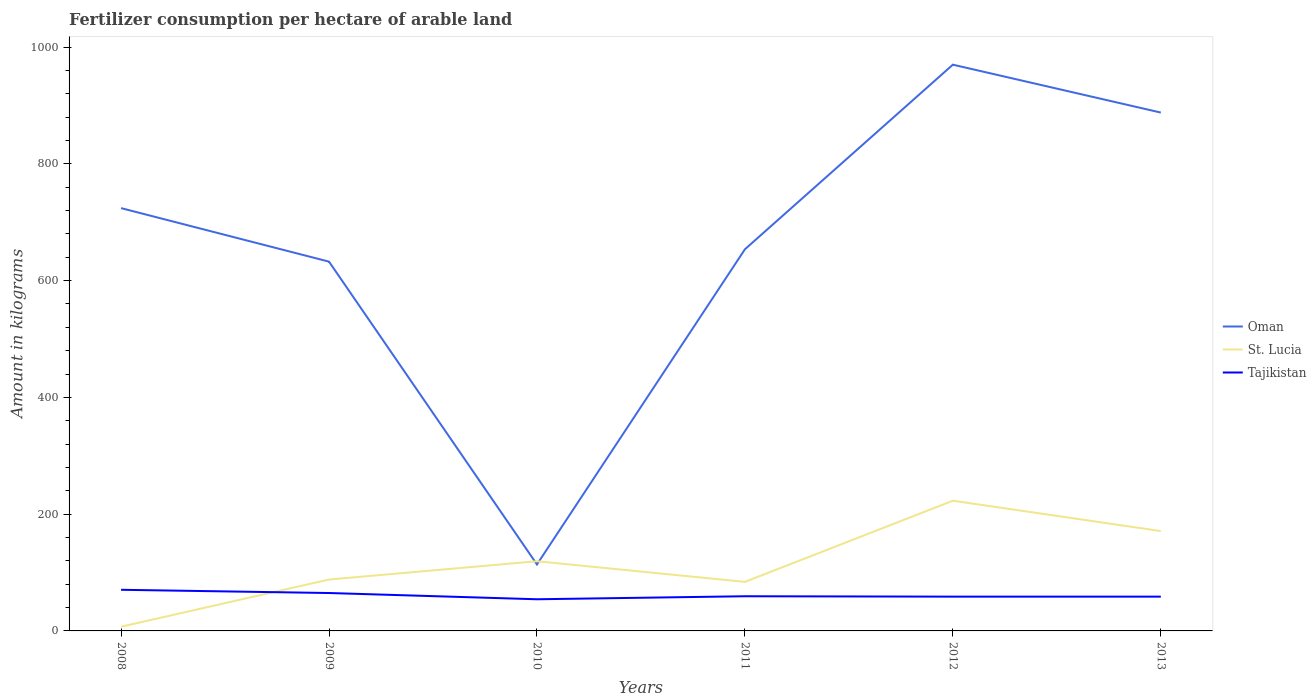Does the line corresponding to Tajikistan intersect with the line corresponding to St. Lucia?
Offer a terse response. Yes. Is the number of lines equal to the number of legend labels?
Keep it short and to the point. Yes. Across all years, what is the maximum amount of fertilizer consumption in Tajikistan?
Your answer should be very brief. 54.22. In which year was the amount of fertilizer consumption in Tajikistan maximum?
Your response must be concise. 2010. What is the total amount of fertilizer consumption in St. Lucia in the graph?
Ensure brevity in your answer.  -80.8. What is the difference between the highest and the second highest amount of fertilizer consumption in Tajikistan?
Provide a succinct answer. 16.23. How many lines are there?
Your response must be concise. 3. Are the values on the major ticks of Y-axis written in scientific E-notation?
Offer a very short reply. No. Where does the legend appear in the graph?
Your answer should be very brief. Center right. How are the legend labels stacked?
Give a very brief answer. Vertical. What is the title of the graph?
Keep it short and to the point. Fertilizer consumption per hectare of arable land. Does "Cyprus" appear as one of the legend labels in the graph?
Make the answer very short. No. What is the label or title of the X-axis?
Ensure brevity in your answer.  Years. What is the label or title of the Y-axis?
Ensure brevity in your answer.  Amount in kilograms. What is the Amount in kilograms in Oman in 2008?
Your answer should be compact. 724.1. What is the Amount in kilograms in St. Lucia in 2008?
Offer a very short reply. 7.2. What is the Amount in kilograms of Tajikistan in 2008?
Your response must be concise. 70.45. What is the Amount in kilograms in Oman in 2009?
Offer a terse response. 632.43. What is the Amount in kilograms of St. Lucia in 2009?
Your answer should be very brief. 88. What is the Amount in kilograms of Tajikistan in 2009?
Ensure brevity in your answer.  64.93. What is the Amount in kilograms of Oman in 2010?
Offer a very short reply. 113.88. What is the Amount in kilograms in St. Lucia in 2010?
Give a very brief answer. 119.33. What is the Amount in kilograms of Tajikistan in 2010?
Keep it short and to the point. 54.22. What is the Amount in kilograms of Oman in 2011?
Make the answer very short. 653.6. What is the Amount in kilograms of St. Lucia in 2011?
Provide a short and direct response. 84. What is the Amount in kilograms of Tajikistan in 2011?
Give a very brief answer. 59.39. What is the Amount in kilograms in Oman in 2012?
Make the answer very short. 969.76. What is the Amount in kilograms in St. Lucia in 2012?
Provide a succinct answer. 223. What is the Amount in kilograms in Tajikistan in 2012?
Provide a short and direct response. 58.72. What is the Amount in kilograms of Oman in 2013?
Your answer should be compact. 887.75. What is the Amount in kilograms in St. Lucia in 2013?
Provide a short and direct response. 171. What is the Amount in kilograms of Tajikistan in 2013?
Offer a very short reply. 58.72. Across all years, what is the maximum Amount in kilograms in Oman?
Offer a terse response. 969.76. Across all years, what is the maximum Amount in kilograms in St. Lucia?
Your answer should be compact. 223. Across all years, what is the maximum Amount in kilograms of Tajikistan?
Your answer should be compact. 70.45. Across all years, what is the minimum Amount in kilograms in Oman?
Provide a short and direct response. 113.88. Across all years, what is the minimum Amount in kilograms in Tajikistan?
Provide a succinct answer. 54.22. What is the total Amount in kilograms of Oman in the graph?
Offer a very short reply. 3981.52. What is the total Amount in kilograms in St. Lucia in the graph?
Ensure brevity in your answer.  692.53. What is the total Amount in kilograms of Tajikistan in the graph?
Make the answer very short. 366.43. What is the difference between the Amount in kilograms in Oman in 2008 and that in 2009?
Your answer should be compact. 91.67. What is the difference between the Amount in kilograms in St. Lucia in 2008 and that in 2009?
Your response must be concise. -80.8. What is the difference between the Amount in kilograms of Tajikistan in 2008 and that in 2009?
Keep it short and to the point. 5.52. What is the difference between the Amount in kilograms in Oman in 2008 and that in 2010?
Your answer should be very brief. 610.22. What is the difference between the Amount in kilograms in St. Lucia in 2008 and that in 2010?
Ensure brevity in your answer.  -112.13. What is the difference between the Amount in kilograms of Tajikistan in 2008 and that in 2010?
Offer a terse response. 16.23. What is the difference between the Amount in kilograms of Oman in 2008 and that in 2011?
Ensure brevity in your answer.  70.5. What is the difference between the Amount in kilograms in St. Lucia in 2008 and that in 2011?
Make the answer very short. -76.8. What is the difference between the Amount in kilograms of Tajikistan in 2008 and that in 2011?
Make the answer very short. 11.05. What is the difference between the Amount in kilograms in Oman in 2008 and that in 2012?
Make the answer very short. -245.66. What is the difference between the Amount in kilograms in St. Lucia in 2008 and that in 2012?
Your answer should be compact. -215.8. What is the difference between the Amount in kilograms in Tajikistan in 2008 and that in 2012?
Ensure brevity in your answer.  11.72. What is the difference between the Amount in kilograms in Oman in 2008 and that in 2013?
Your answer should be compact. -163.65. What is the difference between the Amount in kilograms in St. Lucia in 2008 and that in 2013?
Provide a succinct answer. -163.8. What is the difference between the Amount in kilograms of Tajikistan in 2008 and that in 2013?
Offer a terse response. 11.72. What is the difference between the Amount in kilograms in Oman in 2009 and that in 2010?
Your answer should be compact. 518.55. What is the difference between the Amount in kilograms of St. Lucia in 2009 and that in 2010?
Ensure brevity in your answer.  -31.33. What is the difference between the Amount in kilograms of Tajikistan in 2009 and that in 2010?
Your answer should be compact. 10.71. What is the difference between the Amount in kilograms in Oman in 2009 and that in 2011?
Your answer should be compact. -21.17. What is the difference between the Amount in kilograms of St. Lucia in 2009 and that in 2011?
Offer a very short reply. 4. What is the difference between the Amount in kilograms in Tajikistan in 2009 and that in 2011?
Provide a short and direct response. 5.54. What is the difference between the Amount in kilograms in Oman in 2009 and that in 2012?
Your response must be concise. -337.33. What is the difference between the Amount in kilograms of St. Lucia in 2009 and that in 2012?
Provide a short and direct response. -135. What is the difference between the Amount in kilograms in Tajikistan in 2009 and that in 2012?
Provide a short and direct response. 6.21. What is the difference between the Amount in kilograms in Oman in 2009 and that in 2013?
Keep it short and to the point. -255.31. What is the difference between the Amount in kilograms in St. Lucia in 2009 and that in 2013?
Provide a short and direct response. -83. What is the difference between the Amount in kilograms in Tajikistan in 2009 and that in 2013?
Your answer should be very brief. 6.21. What is the difference between the Amount in kilograms in Oman in 2010 and that in 2011?
Make the answer very short. -539.73. What is the difference between the Amount in kilograms of St. Lucia in 2010 and that in 2011?
Offer a very short reply. 35.33. What is the difference between the Amount in kilograms in Tajikistan in 2010 and that in 2011?
Offer a terse response. -5.17. What is the difference between the Amount in kilograms of Oman in 2010 and that in 2012?
Your response must be concise. -855.89. What is the difference between the Amount in kilograms in St. Lucia in 2010 and that in 2012?
Your answer should be compact. -103.67. What is the difference between the Amount in kilograms of Tajikistan in 2010 and that in 2012?
Provide a succinct answer. -4.5. What is the difference between the Amount in kilograms in Oman in 2010 and that in 2013?
Your response must be concise. -773.87. What is the difference between the Amount in kilograms in St. Lucia in 2010 and that in 2013?
Keep it short and to the point. -51.67. What is the difference between the Amount in kilograms of Tajikistan in 2010 and that in 2013?
Provide a succinct answer. -4.5. What is the difference between the Amount in kilograms of Oman in 2011 and that in 2012?
Offer a terse response. -316.16. What is the difference between the Amount in kilograms in St. Lucia in 2011 and that in 2012?
Offer a terse response. -139. What is the difference between the Amount in kilograms in Tajikistan in 2011 and that in 2012?
Your answer should be very brief. 0.67. What is the difference between the Amount in kilograms in Oman in 2011 and that in 2013?
Provide a short and direct response. -234.14. What is the difference between the Amount in kilograms in St. Lucia in 2011 and that in 2013?
Give a very brief answer. -87. What is the difference between the Amount in kilograms in Tajikistan in 2011 and that in 2013?
Your answer should be very brief. 0.67. What is the difference between the Amount in kilograms of Oman in 2012 and that in 2013?
Give a very brief answer. 82.02. What is the difference between the Amount in kilograms in St. Lucia in 2012 and that in 2013?
Offer a very short reply. 52. What is the difference between the Amount in kilograms of Tajikistan in 2012 and that in 2013?
Make the answer very short. 0. What is the difference between the Amount in kilograms of Oman in 2008 and the Amount in kilograms of St. Lucia in 2009?
Your response must be concise. 636.1. What is the difference between the Amount in kilograms of Oman in 2008 and the Amount in kilograms of Tajikistan in 2009?
Keep it short and to the point. 659.17. What is the difference between the Amount in kilograms in St. Lucia in 2008 and the Amount in kilograms in Tajikistan in 2009?
Offer a very short reply. -57.73. What is the difference between the Amount in kilograms in Oman in 2008 and the Amount in kilograms in St. Lucia in 2010?
Offer a terse response. 604.77. What is the difference between the Amount in kilograms of Oman in 2008 and the Amount in kilograms of Tajikistan in 2010?
Make the answer very short. 669.88. What is the difference between the Amount in kilograms of St. Lucia in 2008 and the Amount in kilograms of Tajikistan in 2010?
Keep it short and to the point. -47.02. What is the difference between the Amount in kilograms in Oman in 2008 and the Amount in kilograms in St. Lucia in 2011?
Provide a succinct answer. 640.1. What is the difference between the Amount in kilograms in Oman in 2008 and the Amount in kilograms in Tajikistan in 2011?
Offer a terse response. 664.71. What is the difference between the Amount in kilograms of St. Lucia in 2008 and the Amount in kilograms of Tajikistan in 2011?
Provide a short and direct response. -52.19. What is the difference between the Amount in kilograms in Oman in 2008 and the Amount in kilograms in St. Lucia in 2012?
Provide a succinct answer. 501.1. What is the difference between the Amount in kilograms of Oman in 2008 and the Amount in kilograms of Tajikistan in 2012?
Offer a very short reply. 665.38. What is the difference between the Amount in kilograms of St. Lucia in 2008 and the Amount in kilograms of Tajikistan in 2012?
Make the answer very short. -51.52. What is the difference between the Amount in kilograms of Oman in 2008 and the Amount in kilograms of St. Lucia in 2013?
Your answer should be compact. 553.1. What is the difference between the Amount in kilograms in Oman in 2008 and the Amount in kilograms in Tajikistan in 2013?
Keep it short and to the point. 665.38. What is the difference between the Amount in kilograms in St. Lucia in 2008 and the Amount in kilograms in Tajikistan in 2013?
Your response must be concise. -51.52. What is the difference between the Amount in kilograms of Oman in 2009 and the Amount in kilograms of St. Lucia in 2010?
Keep it short and to the point. 513.1. What is the difference between the Amount in kilograms of Oman in 2009 and the Amount in kilograms of Tajikistan in 2010?
Provide a short and direct response. 578.21. What is the difference between the Amount in kilograms in St. Lucia in 2009 and the Amount in kilograms in Tajikistan in 2010?
Keep it short and to the point. 33.78. What is the difference between the Amount in kilograms of Oman in 2009 and the Amount in kilograms of St. Lucia in 2011?
Give a very brief answer. 548.43. What is the difference between the Amount in kilograms of Oman in 2009 and the Amount in kilograms of Tajikistan in 2011?
Your answer should be compact. 573.04. What is the difference between the Amount in kilograms in St. Lucia in 2009 and the Amount in kilograms in Tajikistan in 2011?
Give a very brief answer. 28.61. What is the difference between the Amount in kilograms in Oman in 2009 and the Amount in kilograms in St. Lucia in 2012?
Provide a short and direct response. 409.43. What is the difference between the Amount in kilograms in Oman in 2009 and the Amount in kilograms in Tajikistan in 2012?
Provide a succinct answer. 573.71. What is the difference between the Amount in kilograms of St. Lucia in 2009 and the Amount in kilograms of Tajikistan in 2012?
Provide a short and direct response. 29.28. What is the difference between the Amount in kilograms in Oman in 2009 and the Amount in kilograms in St. Lucia in 2013?
Your response must be concise. 461.43. What is the difference between the Amount in kilograms in Oman in 2009 and the Amount in kilograms in Tajikistan in 2013?
Provide a succinct answer. 573.71. What is the difference between the Amount in kilograms of St. Lucia in 2009 and the Amount in kilograms of Tajikistan in 2013?
Keep it short and to the point. 29.28. What is the difference between the Amount in kilograms of Oman in 2010 and the Amount in kilograms of St. Lucia in 2011?
Your response must be concise. 29.88. What is the difference between the Amount in kilograms in Oman in 2010 and the Amount in kilograms in Tajikistan in 2011?
Your answer should be very brief. 54.49. What is the difference between the Amount in kilograms in St. Lucia in 2010 and the Amount in kilograms in Tajikistan in 2011?
Provide a short and direct response. 59.94. What is the difference between the Amount in kilograms in Oman in 2010 and the Amount in kilograms in St. Lucia in 2012?
Ensure brevity in your answer.  -109.12. What is the difference between the Amount in kilograms of Oman in 2010 and the Amount in kilograms of Tajikistan in 2012?
Give a very brief answer. 55.16. What is the difference between the Amount in kilograms in St. Lucia in 2010 and the Amount in kilograms in Tajikistan in 2012?
Your response must be concise. 60.61. What is the difference between the Amount in kilograms of Oman in 2010 and the Amount in kilograms of St. Lucia in 2013?
Offer a very short reply. -57.12. What is the difference between the Amount in kilograms of Oman in 2010 and the Amount in kilograms of Tajikistan in 2013?
Provide a short and direct response. 55.16. What is the difference between the Amount in kilograms in St. Lucia in 2010 and the Amount in kilograms in Tajikistan in 2013?
Give a very brief answer. 60.61. What is the difference between the Amount in kilograms of Oman in 2011 and the Amount in kilograms of St. Lucia in 2012?
Ensure brevity in your answer.  430.6. What is the difference between the Amount in kilograms in Oman in 2011 and the Amount in kilograms in Tajikistan in 2012?
Your answer should be very brief. 594.88. What is the difference between the Amount in kilograms of St. Lucia in 2011 and the Amount in kilograms of Tajikistan in 2012?
Offer a very short reply. 25.28. What is the difference between the Amount in kilograms in Oman in 2011 and the Amount in kilograms in St. Lucia in 2013?
Offer a terse response. 482.6. What is the difference between the Amount in kilograms of Oman in 2011 and the Amount in kilograms of Tajikistan in 2013?
Your response must be concise. 594.88. What is the difference between the Amount in kilograms of St. Lucia in 2011 and the Amount in kilograms of Tajikistan in 2013?
Your answer should be very brief. 25.28. What is the difference between the Amount in kilograms of Oman in 2012 and the Amount in kilograms of St. Lucia in 2013?
Ensure brevity in your answer.  798.76. What is the difference between the Amount in kilograms in Oman in 2012 and the Amount in kilograms in Tajikistan in 2013?
Offer a terse response. 911.04. What is the difference between the Amount in kilograms in St. Lucia in 2012 and the Amount in kilograms in Tajikistan in 2013?
Offer a very short reply. 164.28. What is the average Amount in kilograms in Oman per year?
Offer a very short reply. 663.59. What is the average Amount in kilograms in St. Lucia per year?
Provide a short and direct response. 115.42. What is the average Amount in kilograms in Tajikistan per year?
Your response must be concise. 61.07. In the year 2008, what is the difference between the Amount in kilograms of Oman and Amount in kilograms of St. Lucia?
Keep it short and to the point. 716.9. In the year 2008, what is the difference between the Amount in kilograms in Oman and Amount in kilograms in Tajikistan?
Offer a very short reply. 653.65. In the year 2008, what is the difference between the Amount in kilograms of St. Lucia and Amount in kilograms of Tajikistan?
Ensure brevity in your answer.  -63.25. In the year 2009, what is the difference between the Amount in kilograms of Oman and Amount in kilograms of St. Lucia?
Provide a succinct answer. 544.43. In the year 2009, what is the difference between the Amount in kilograms of Oman and Amount in kilograms of Tajikistan?
Your response must be concise. 567.51. In the year 2009, what is the difference between the Amount in kilograms of St. Lucia and Amount in kilograms of Tajikistan?
Keep it short and to the point. 23.07. In the year 2010, what is the difference between the Amount in kilograms of Oman and Amount in kilograms of St. Lucia?
Make the answer very short. -5.46. In the year 2010, what is the difference between the Amount in kilograms of Oman and Amount in kilograms of Tajikistan?
Your answer should be compact. 59.66. In the year 2010, what is the difference between the Amount in kilograms in St. Lucia and Amount in kilograms in Tajikistan?
Provide a short and direct response. 65.11. In the year 2011, what is the difference between the Amount in kilograms in Oman and Amount in kilograms in St. Lucia?
Make the answer very short. 569.6. In the year 2011, what is the difference between the Amount in kilograms of Oman and Amount in kilograms of Tajikistan?
Your answer should be compact. 594.21. In the year 2011, what is the difference between the Amount in kilograms of St. Lucia and Amount in kilograms of Tajikistan?
Provide a succinct answer. 24.61. In the year 2012, what is the difference between the Amount in kilograms in Oman and Amount in kilograms in St. Lucia?
Your response must be concise. 746.76. In the year 2012, what is the difference between the Amount in kilograms in Oman and Amount in kilograms in Tajikistan?
Provide a succinct answer. 911.04. In the year 2012, what is the difference between the Amount in kilograms of St. Lucia and Amount in kilograms of Tajikistan?
Your response must be concise. 164.28. In the year 2013, what is the difference between the Amount in kilograms of Oman and Amount in kilograms of St. Lucia?
Offer a very short reply. 716.75. In the year 2013, what is the difference between the Amount in kilograms in Oman and Amount in kilograms in Tajikistan?
Keep it short and to the point. 829.02. In the year 2013, what is the difference between the Amount in kilograms of St. Lucia and Amount in kilograms of Tajikistan?
Your response must be concise. 112.28. What is the ratio of the Amount in kilograms of Oman in 2008 to that in 2009?
Ensure brevity in your answer.  1.14. What is the ratio of the Amount in kilograms in St. Lucia in 2008 to that in 2009?
Provide a succinct answer. 0.08. What is the ratio of the Amount in kilograms in Tajikistan in 2008 to that in 2009?
Keep it short and to the point. 1.08. What is the ratio of the Amount in kilograms of Oman in 2008 to that in 2010?
Your response must be concise. 6.36. What is the ratio of the Amount in kilograms of St. Lucia in 2008 to that in 2010?
Your answer should be compact. 0.06. What is the ratio of the Amount in kilograms of Tajikistan in 2008 to that in 2010?
Offer a terse response. 1.3. What is the ratio of the Amount in kilograms in Oman in 2008 to that in 2011?
Your response must be concise. 1.11. What is the ratio of the Amount in kilograms in St. Lucia in 2008 to that in 2011?
Your response must be concise. 0.09. What is the ratio of the Amount in kilograms in Tajikistan in 2008 to that in 2011?
Keep it short and to the point. 1.19. What is the ratio of the Amount in kilograms in Oman in 2008 to that in 2012?
Provide a short and direct response. 0.75. What is the ratio of the Amount in kilograms of St. Lucia in 2008 to that in 2012?
Ensure brevity in your answer.  0.03. What is the ratio of the Amount in kilograms in Tajikistan in 2008 to that in 2012?
Make the answer very short. 1.2. What is the ratio of the Amount in kilograms in Oman in 2008 to that in 2013?
Offer a terse response. 0.82. What is the ratio of the Amount in kilograms in St. Lucia in 2008 to that in 2013?
Your response must be concise. 0.04. What is the ratio of the Amount in kilograms in Tajikistan in 2008 to that in 2013?
Ensure brevity in your answer.  1.2. What is the ratio of the Amount in kilograms in Oman in 2009 to that in 2010?
Provide a short and direct response. 5.55. What is the ratio of the Amount in kilograms of St. Lucia in 2009 to that in 2010?
Offer a terse response. 0.74. What is the ratio of the Amount in kilograms of Tajikistan in 2009 to that in 2010?
Offer a very short reply. 1.2. What is the ratio of the Amount in kilograms of Oman in 2009 to that in 2011?
Give a very brief answer. 0.97. What is the ratio of the Amount in kilograms in St. Lucia in 2009 to that in 2011?
Your answer should be compact. 1.05. What is the ratio of the Amount in kilograms of Tajikistan in 2009 to that in 2011?
Keep it short and to the point. 1.09. What is the ratio of the Amount in kilograms of Oman in 2009 to that in 2012?
Keep it short and to the point. 0.65. What is the ratio of the Amount in kilograms in St. Lucia in 2009 to that in 2012?
Provide a short and direct response. 0.39. What is the ratio of the Amount in kilograms in Tajikistan in 2009 to that in 2012?
Your answer should be compact. 1.11. What is the ratio of the Amount in kilograms in Oman in 2009 to that in 2013?
Give a very brief answer. 0.71. What is the ratio of the Amount in kilograms of St. Lucia in 2009 to that in 2013?
Make the answer very short. 0.51. What is the ratio of the Amount in kilograms of Tajikistan in 2009 to that in 2013?
Your response must be concise. 1.11. What is the ratio of the Amount in kilograms in Oman in 2010 to that in 2011?
Provide a succinct answer. 0.17. What is the ratio of the Amount in kilograms of St. Lucia in 2010 to that in 2011?
Give a very brief answer. 1.42. What is the ratio of the Amount in kilograms of Tajikistan in 2010 to that in 2011?
Offer a very short reply. 0.91. What is the ratio of the Amount in kilograms in Oman in 2010 to that in 2012?
Make the answer very short. 0.12. What is the ratio of the Amount in kilograms in St. Lucia in 2010 to that in 2012?
Offer a terse response. 0.54. What is the ratio of the Amount in kilograms of Tajikistan in 2010 to that in 2012?
Keep it short and to the point. 0.92. What is the ratio of the Amount in kilograms in Oman in 2010 to that in 2013?
Ensure brevity in your answer.  0.13. What is the ratio of the Amount in kilograms in St. Lucia in 2010 to that in 2013?
Your response must be concise. 0.7. What is the ratio of the Amount in kilograms of Tajikistan in 2010 to that in 2013?
Ensure brevity in your answer.  0.92. What is the ratio of the Amount in kilograms in Oman in 2011 to that in 2012?
Your answer should be compact. 0.67. What is the ratio of the Amount in kilograms in St. Lucia in 2011 to that in 2012?
Provide a succinct answer. 0.38. What is the ratio of the Amount in kilograms of Tajikistan in 2011 to that in 2012?
Your answer should be compact. 1.01. What is the ratio of the Amount in kilograms of Oman in 2011 to that in 2013?
Offer a terse response. 0.74. What is the ratio of the Amount in kilograms of St. Lucia in 2011 to that in 2013?
Offer a very short reply. 0.49. What is the ratio of the Amount in kilograms of Tajikistan in 2011 to that in 2013?
Make the answer very short. 1.01. What is the ratio of the Amount in kilograms of Oman in 2012 to that in 2013?
Give a very brief answer. 1.09. What is the ratio of the Amount in kilograms of St. Lucia in 2012 to that in 2013?
Keep it short and to the point. 1.3. What is the difference between the highest and the second highest Amount in kilograms of Oman?
Keep it short and to the point. 82.02. What is the difference between the highest and the second highest Amount in kilograms of Tajikistan?
Provide a succinct answer. 5.52. What is the difference between the highest and the lowest Amount in kilograms of Oman?
Offer a very short reply. 855.89. What is the difference between the highest and the lowest Amount in kilograms of St. Lucia?
Offer a terse response. 215.8. What is the difference between the highest and the lowest Amount in kilograms of Tajikistan?
Provide a succinct answer. 16.23. 